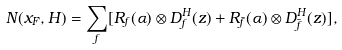<formula> <loc_0><loc_0><loc_500><loc_500>N ( x _ { F } , H ) = \sum _ { f } [ R _ { f } ( \alpha ) \otimes D _ { f } ^ { H } ( z ) + R _ { \bar { f } } ( \alpha ) \otimes D _ { \bar { f } } ^ { H } ( z ) ] ,</formula> 